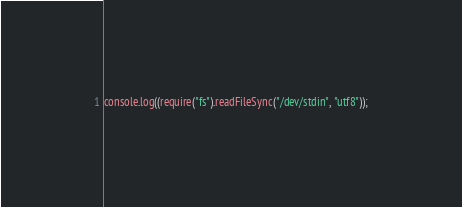<code> <loc_0><loc_0><loc_500><loc_500><_JavaScript_>


console.log((require("fs").readFileSync("/dev/stdin", "utf8"));</code> 